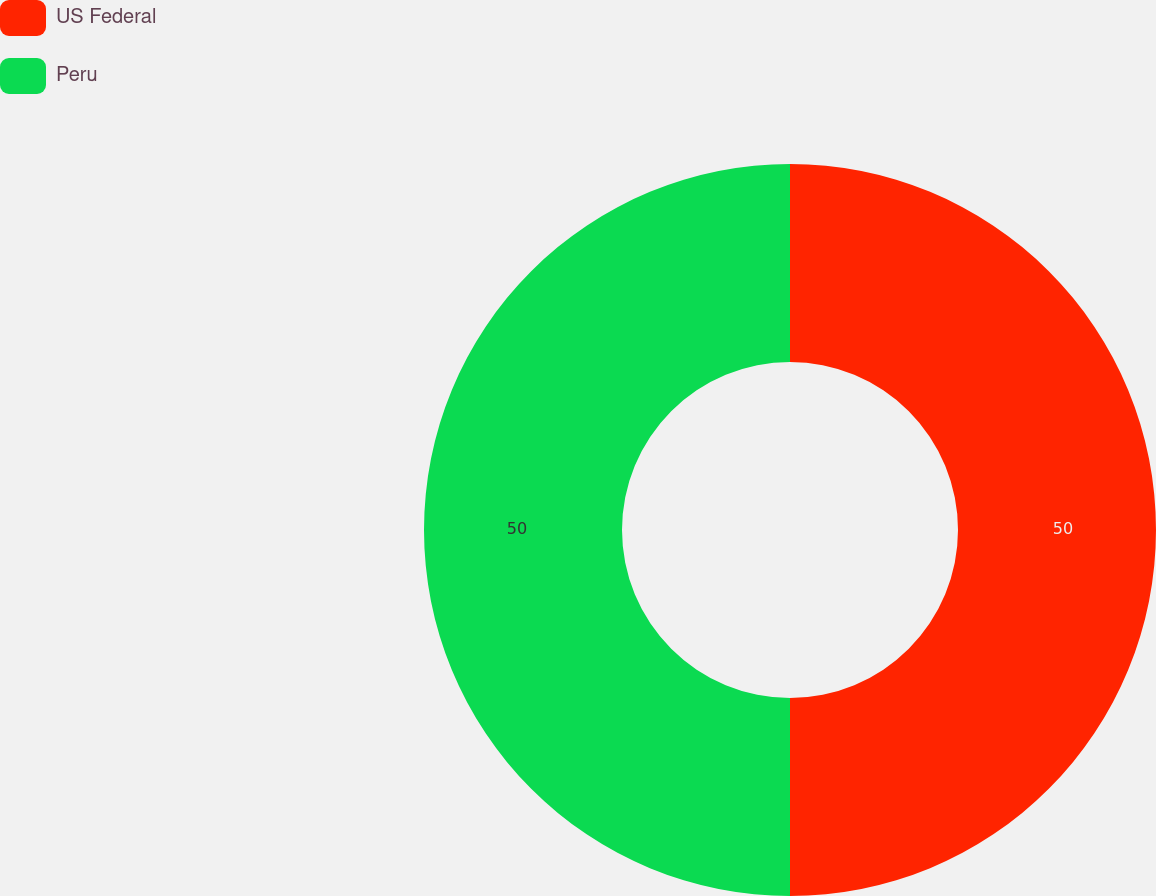Convert chart to OTSL. <chart><loc_0><loc_0><loc_500><loc_500><pie_chart><fcel>US Federal<fcel>Peru<nl><fcel>50.0%<fcel>50.0%<nl></chart> 